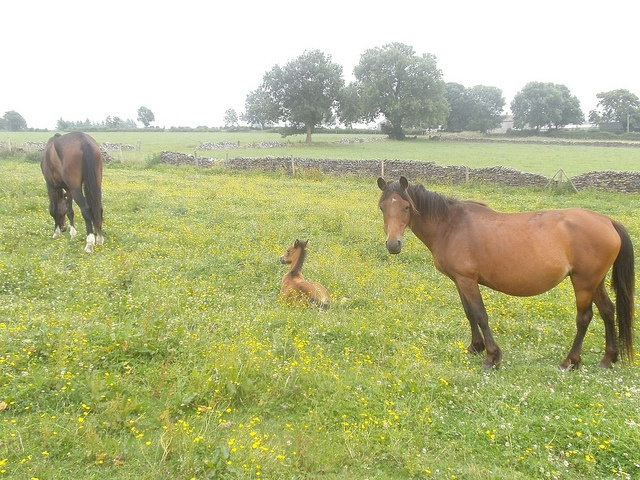Describe the objects in this image and their specific colors. I can see horse in white, gray, and tan tones, horse in white, gray, tan, and darkgray tones, and horse in white, tan, and gray tones in this image. 